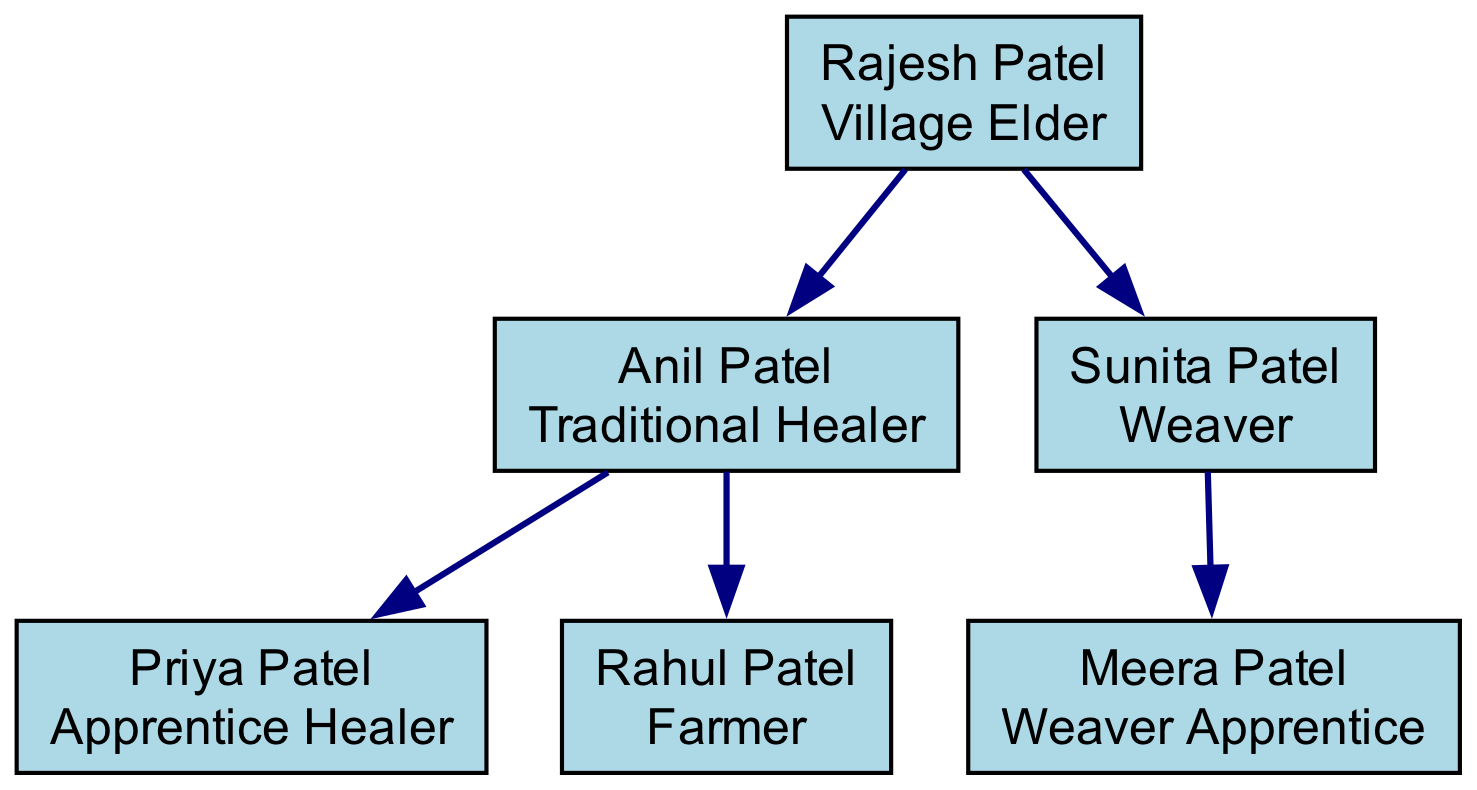What is the role of Rajesh Patel? The diagram specifies that Rajesh Patel, the root of the family tree, holds the position of "Village Elder." This information is obtained directly from his node in the diagram.
Answer: Village Elder How many children does Anil Patel have? According to the children listed under Anil Patel, there are two: Priya Patel and Rahul Patel. This can be confirmed by counting the entries in Anil Patel's child list.
Answer: 2 Who is the apprentice of the traditional healer? The diagram indicates that Priya Patel is labeled as "Apprentice Healer" under Anil Patel, confirming that she is the apprentice to the traditional healer.
Answer: Priya Patel What is the relationship between Sunita Patel and Meera Patel? The diagram shows that Sunita Patel is listed as the parent of Meera Patel, indicating that Meera is her child. This is evident from the hierarchical structure of the family tree.
Answer: Mother and Daughter Which role is inherited by the next generation from Anil Patel? The diagram illustrates that Priya Patel is inheriting the role of "Traditional Healer" from her father, Anil Patel, as an apprentice. This is derived from the direct lineage and role description.
Answer: Traditional Healer How many total family roles are represented in the diagram? The roles represented consist of the Village Elder, Traditional Healer, Apprentice Healer, Farmer, Weaver, and Weaver Apprentice, totaling six unique roles which can be counted from the nodes in the diagram.
Answer: 6 Who holds the role of Weaver in the family? In the diagram, it is specified that Sunita Patel holds the role of "Weaver," which can be seen directly under her name as part of the family structure.
Answer: Sunita Patel How is the role of farming represented in the lineage? The diagram shows that Rahul Patel, a child of Anil Patel, is identified with the role of "Farmer," indicating this role is passed down in this lineage. This can be confirmed by examining Rahul Patel's node.
Answer: Farmer 